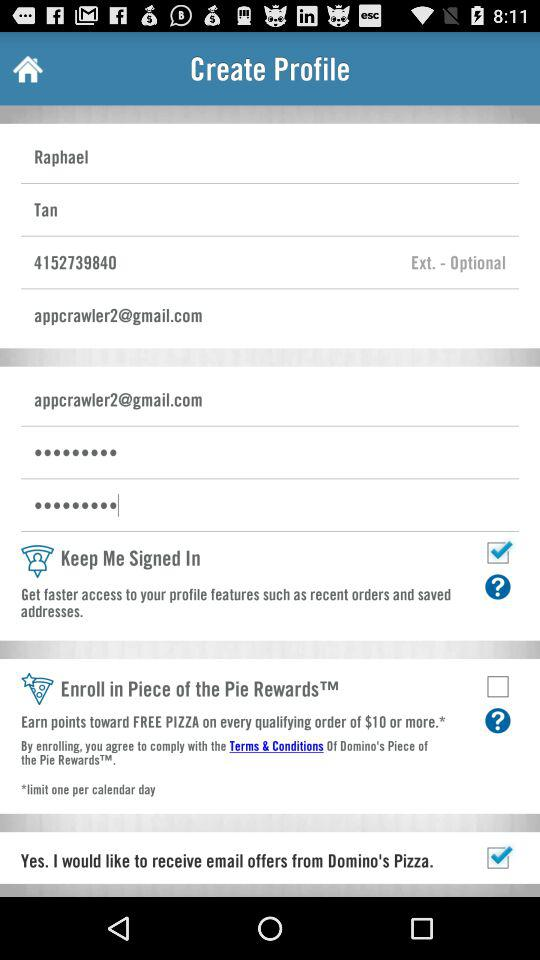From where does the person want to receive email? The person wants to receive email from Domino's Pizza. 